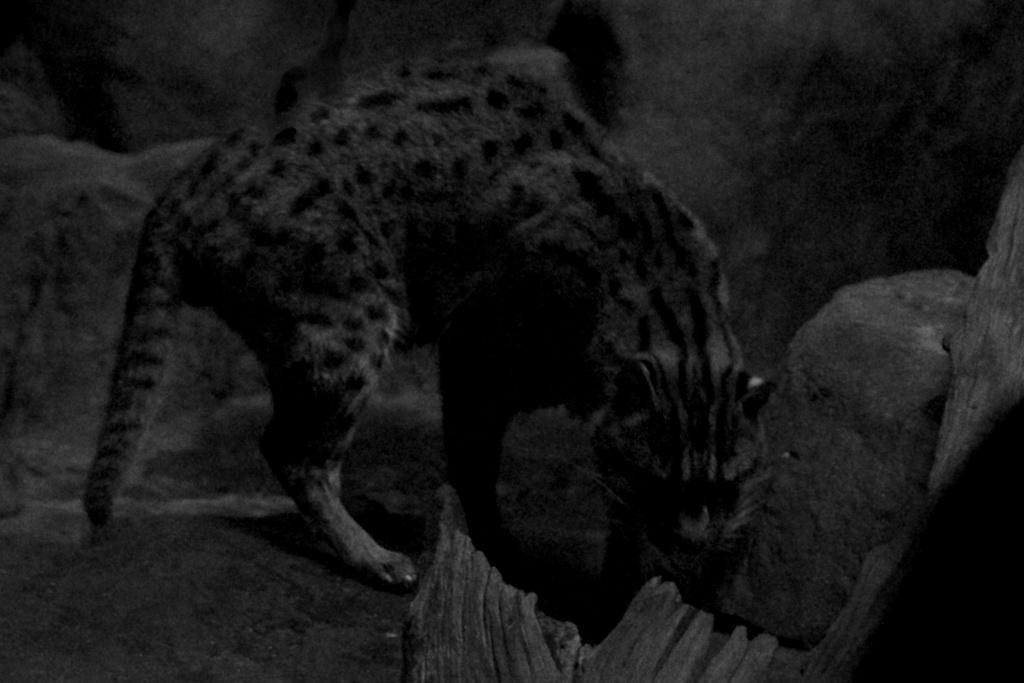What animal is present in the image? There is a cheetah in the image. Where is the cheetah located in the image? The cheetah is on the ground. What type of map can be seen in the cheetah's mouth in the image? There is no map present in the image, and the cheetah's mouth is not visible. 